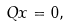Convert formula to latex. <formula><loc_0><loc_0><loc_500><loc_500>Q x = 0 ,</formula> 